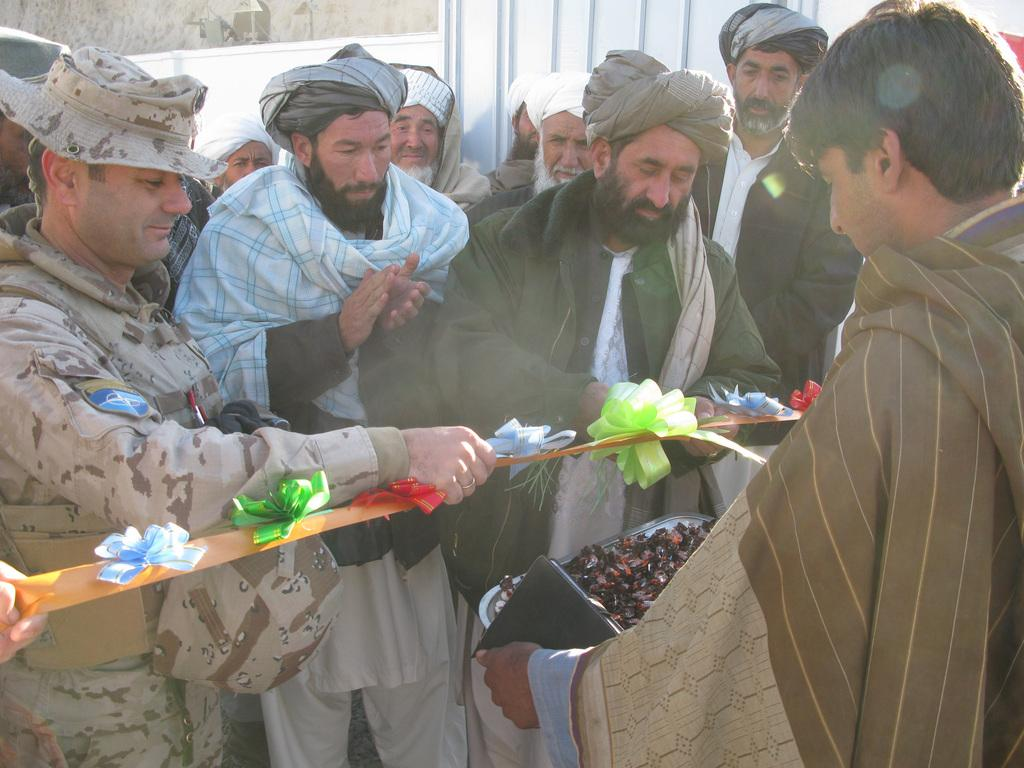What is the main subject of the image? The main subject of the image is a group of men. What are two men in the group doing? Two men in the group are holding a ribbon. Can you describe the actions of the other individuals in the image? There is a person holding a book and another person holding a tray. What type of poison is being used by the person holding the book in the image? There is no mention of poison in the image, and the person holding the book is not using any poison. How many chickens are present in the image? There are no chickens present in the image. 